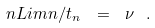Convert formula to latex. <formula><loc_0><loc_0><loc_500><loc_500>\ n L i m n / t _ { n } \ = \ \nu \ .</formula> 